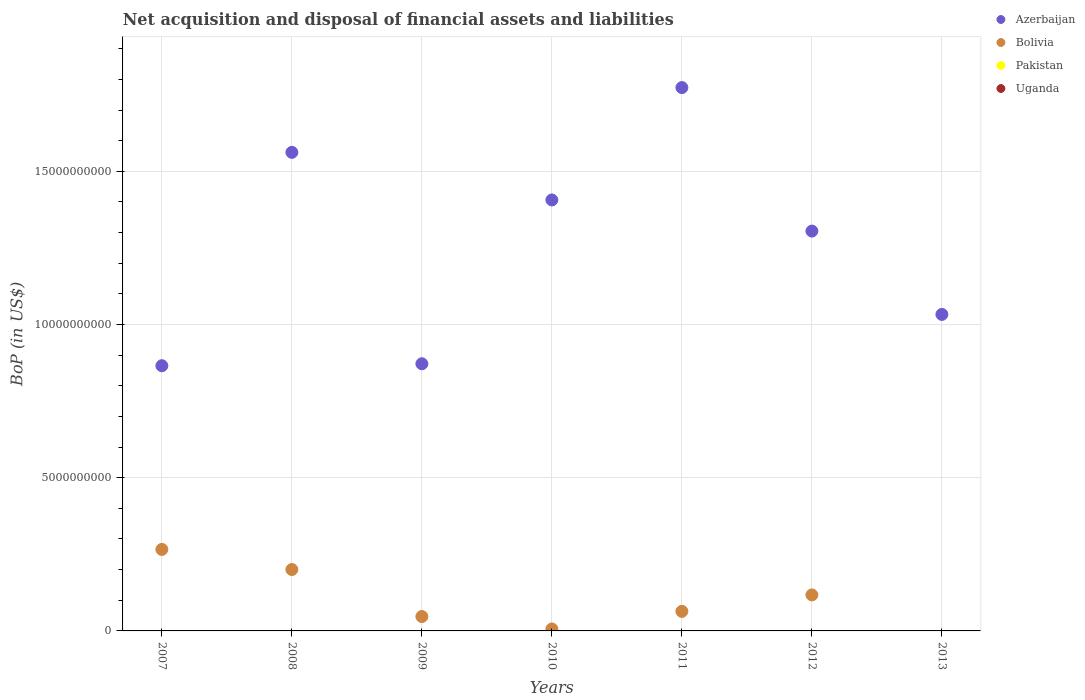How many different coloured dotlines are there?
Your response must be concise. 2. Is the number of dotlines equal to the number of legend labels?
Your answer should be very brief. No. Across all years, what is the maximum Balance of Payments in Bolivia?
Make the answer very short. 2.66e+09. Across all years, what is the minimum Balance of Payments in Azerbaijan?
Your answer should be very brief. 8.66e+09. What is the total Balance of Payments in Azerbaijan in the graph?
Provide a short and direct response. 8.82e+1. What is the difference between the Balance of Payments in Azerbaijan in 2008 and that in 2013?
Keep it short and to the point. 5.29e+09. What is the difference between the Balance of Payments in Azerbaijan in 2010 and the Balance of Payments in Uganda in 2012?
Your answer should be very brief. 1.41e+1. In the year 2012, what is the difference between the Balance of Payments in Bolivia and Balance of Payments in Azerbaijan?
Offer a terse response. -1.19e+1. In how many years, is the Balance of Payments in Bolivia greater than 4000000000 US$?
Give a very brief answer. 0. What is the ratio of the Balance of Payments in Azerbaijan in 2009 to that in 2012?
Offer a terse response. 0.67. What is the difference between the highest and the second highest Balance of Payments in Azerbaijan?
Your answer should be compact. 2.11e+09. What is the difference between the highest and the lowest Balance of Payments in Bolivia?
Your response must be concise. 2.66e+09. Is it the case that in every year, the sum of the Balance of Payments in Azerbaijan and Balance of Payments in Bolivia  is greater than the Balance of Payments in Uganda?
Offer a terse response. Yes. Does the Balance of Payments in Uganda monotonically increase over the years?
Give a very brief answer. No. Is the Balance of Payments in Uganda strictly less than the Balance of Payments in Azerbaijan over the years?
Provide a short and direct response. Yes. What is the difference between two consecutive major ticks on the Y-axis?
Your response must be concise. 5.00e+09. Does the graph contain any zero values?
Provide a succinct answer. Yes. Does the graph contain grids?
Offer a terse response. Yes. How many legend labels are there?
Offer a terse response. 4. What is the title of the graph?
Provide a succinct answer. Net acquisition and disposal of financial assets and liabilities. Does "Trinidad and Tobago" appear as one of the legend labels in the graph?
Make the answer very short. No. What is the label or title of the X-axis?
Offer a terse response. Years. What is the label or title of the Y-axis?
Your response must be concise. BoP (in US$). What is the BoP (in US$) in Azerbaijan in 2007?
Offer a terse response. 8.66e+09. What is the BoP (in US$) of Bolivia in 2007?
Keep it short and to the point. 2.66e+09. What is the BoP (in US$) in Uganda in 2007?
Ensure brevity in your answer.  0. What is the BoP (in US$) in Azerbaijan in 2008?
Provide a short and direct response. 1.56e+1. What is the BoP (in US$) in Bolivia in 2008?
Ensure brevity in your answer.  2.00e+09. What is the BoP (in US$) in Uganda in 2008?
Provide a short and direct response. 0. What is the BoP (in US$) of Azerbaijan in 2009?
Give a very brief answer. 8.72e+09. What is the BoP (in US$) of Bolivia in 2009?
Offer a terse response. 4.71e+08. What is the BoP (in US$) in Pakistan in 2009?
Give a very brief answer. 0. What is the BoP (in US$) of Azerbaijan in 2010?
Give a very brief answer. 1.41e+1. What is the BoP (in US$) of Bolivia in 2010?
Offer a terse response. 6.43e+07. What is the BoP (in US$) of Uganda in 2010?
Give a very brief answer. 0. What is the BoP (in US$) of Azerbaijan in 2011?
Make the answer very short. 1.77e+1. What is the BoP (in US$) in Bolivia in 2011?
Your answer should be very brief. 6.38e+08. What is the BoP (in US$) of Pakistan in 2011?
Provide a succinct answer. 0. What is the BoP (in US$) of Azerbaijan in 2012?
Provide a succinct answer. 1.30e+1. What is the BoP (in US$) of Bolivia in 2012?
Offer a very short reply. 1.18e+09. What is the BoP (in US$) in Pakistan in 2012?
Provide a succinct answer. 0. What is the BoP (in US$) in Uganda in 2012?
Your answer should be very brief. 0. What is the BoP (in US$) in Azerbaijan in 2013?
Ensure brevity in your answer.  1.03e+1. What is the BoP (in US$) of Bolivia in 2013?
Your answer should be compact. 0. Across all years, what is the maximum BoP (in US$) in Azerbaijan?
Ensure brevity in your answer.  1.77e+1. Across all years, what is the maximum BoP (in US$) in Bolivia?
Offer a terse response. 2.66e+09. Across all years, what is the minimum BoP (in US$) in Azerbaijan?
Make the answer very short. 8.66e+09. Across all years, what is the minimum BoP (in US$) of Bolivia?
Provide a short and direct response. 0. What is the total BoP (in US$) of Azerbaijan in the graph?
Your answer should be compact. 8.82e+1. What is the total BoP (in US$) in Bolivia in the graph?
Offer a terse response. 7.01e+09. What is the difference between the BoP (in US$) of Azerbaijan in 2007 and that in 2008?
Provide a succinct answer. -6.96e+09. What is the difference between the BoP (in US$) of Bolivia in 2007 and that in 2008?
Provide a short and direct response. 6.56e+08. What is the difference between the BoP (in US$) in Azerbaijan in 2007 and that in 2009?
Give a very brief answer. -6.39e+07. What is the difference between the BoP (in US$) in Bolivia in 2007 and that in 2009?
Offer a very short reply. 2.19e+09. What is the difference between the BoP (in US$) in Azerbaijan in 2007 and that in 2010?
Offer a very short reply. -5.41e+09. What is the difference between the BoP (in US$) in Bolivia in 2007 and that in 2010?
Give a very brief answer. 2.60e+09. What is the difference between the BoP (in US$) in Azerbaijan in 2007 and that in 2011?
Ensure brevity in your answer.  -9.08e+09. What is the difference between the BoP (in US$) of Bolivia in 2007 and that in 2011?
Your response must be concise. 2.02e+09. What is the difference between the BoP (in US$) of Azerbaijan in 2007 and that in 2012?
Offer a terse response. -4.39e+09. What is the difference between the BoP (in US$) in Bolivia in 2007 and that in 2012?
Provide a short and direct response. 1.48e+09. What is the difference between the BoP (in US$) of Azerbaijan in 2007 and that in 2013?
Make the answer very short. -1.67e+09. What is the difference between the BoP (in US$) in Azerbaijan in 2008 and that in 2009?
Your answer should be compact. 6.90e+09. What is the difference between the BoP (in US$) of Bolivia in 2008 and that in 2009?
Keep it short and to the point. 1.53e+09. What is the difference between the BoP (in US$) in Azerbaijan in 2008 and that in 2010?
Ensure brevity in your answer.  1.55e+09. What is the difference between the BoP (in US$) in Bolivia in 2008 and that in 2010?
Ensure brevity in your answer.  1.94e+09. What is the difference between the BoP (in US$) of Azerbaijan in 2008 and that in 2011?
Give a very brief answer. -2.11e+09. What is the difference between the BoP (in US$) in Bolivia in 2008 and that in 2011?
Provide a short and direct response. 1.37e+09. What is the difference between the BoP (in US$) of Azerbaijan in 2008 and that in 2012?
Provide a short and direct response. 2.57e+09. What is the difference between the BoP (in US$) of Bolivia in 2008 and that in 2012?
Make the answer very short. 8.28e+08. What is the difference between the BoP (in US$) in Azerbaijan in 2008 and that in 2013?
Keep it short and to the point. 5.29e+09. What is the difference between the BoP (in US$) in Azerbaijan in 2009 and that in 2010?
Your answer should be very brief. -5.35e+09. What is the difference between the BoP (in US$) in Bolivia in 2009 and that in 2010?
Make the answer very short. 4.06e+08. What is the difference between the BoP (in US$) in Azerbaijan in 2009 and that in 2011?
Your answer should be very brief. -9.01e+09. What is the difference between the BoP (in US$) in Bolivia in 2009 and that in 2011?
Offer a terse response. -1.67e+08. What is the difference between the BoP (in US$) in Azerbaijan in 2009 and that in 2012?
Give a very brief answer. -4.33e+09. What is the difference between the BoP (in US$) in Bolivia in 2009 and that in 2012?
Provide a succinct answer. -7.05e+08. What is the difference between the BoP (in US$) of Azerbaijan in 2009 and that in 2013?
Offer a terse response. -1.61e+09. What is the difference between the BoP (in US$) of Azerbaijan in 2010 and that in 2011?
Provide a succinct answer. -3.67e+09. What is the difference between the BoP (in US$) in Bolivia in 2010 and that in 2011?
Provide a succinct answer. -5.74e+08. What is the difference between the BoP (in US$) in Azerbaijan in 2010 and that in 2012?
Keep it short and to the point. 1.02e+09. What is the difference between the BoP (in US$) in Bolivia in 2010 and that in 2012?
Give a very brief answer. -1.11e+09. What is the difference between the BoP (in US$) in Azerbaijan in 2010 and that in 2013?
Give a very brief answer. 3.74e+09. What is the difference between the BoP (in US$) of Azerbaijan in 2011 and that in 2012?
Provide a succinct answer. 4.68e+09. What is the difference between the BoP (in US$) in Bolivia in 2011 and that in 2012?
Ensure brevity in your answer.  -5.38e+08. What is the difference between the BoP (in US$) in Azerbaijan in 2011 and that in 2013?
Provide a short and direct response. 7.40e+09. What is the difference between the BoP (in US$) in Azerbaijan in 2012 and that in 2013?
Give a very brief answer. 2.72e+09. What is the difference between the BoP (in US$) of Azerbaijan in 2007 and the BoP (in US$) of Bolivia in 2008?
Keep it short and to the point. 6.65e+09. What is the difference between the BoP (in US$) of Azerbaijan in 2007 and the BoP (in US$) of Bolivia in 2009?
Offer a very short reply. 8.18e+09. What is the difference between the BoP (in US$) of Azerbaijan in 2007 and the BoP (in US$) of Bolivia in 2010?
Offer a very short reply. 8.59e+09. What is the difference between the BoP (in US$) of Azerbaijan in 2007 and the BoP (in US$) of Bolivia in 2011?
Offer a terse response. 8.02e+09. What is the difference between the BoP (in US$) of Azerbaijan in 2007 and the BoP (in US$) of Bolivia in 2012?
Make the answer very short. 7.48e+09. What is the difference between the BoP (in US$) in Azerbaijan in 2008 and the BoP (in US$) in Bolivia in 2009?
Offer a terse response. 1.51e+1. What is the difference between the BoP (in US$) in Azerbaijan in 2008 and the BoP (in US$) in Bolivia in 2010?
Keep it short and to the point. 1.56e+1. What is the difference between the BoP (in US$) in Azerbaijan in 2008 and the BoP (in US$) in Bolivia in 2011?
Offer a terse response. 1.50e+1. What is the difference between the BoP (in US$) in Azerbaijan in 2008 and the BoP (in US$) in Bolivia in 2012?
Your answer should be very brief. 1.44e+1. What is the difference between the BoP (in US$) in Azerbaijan in 2009 and the BoP (in US$) in Bolivia in 2010?
Make the answer very short. 8.65e+09. What is the difference between the BoP (in US$) in Azerbaijan in 2009 and the BoP (in US$) in Bolivia in 2011?
Your answer should be very brief. 8.08e+09. What is the difference between the BoP (in US$) in Azerbaijan in 2009 and the BoP (in US$) in Bolivia in 2012?
Offer a very short reply. 7.54e+09. What is the difference between the BoP (in US$) in Azerbaijan in 2010 and the BoP (in US$) in Bolivia in 2011?
Offer a terse response. 1.34e+1. What is the difference between the BoP (in US$) in Azerbaijan in 2010 and the BoP (in US$) in Bolivia in 2012?
Make the answer very short. 1.29e+1. What is the difference between the BoP (in US$) of Azerbaijan in 2011 and the BoP (in US$) of Bolivia in 2012?
Provide a succinct answer. 1.66e+1. What is the average BoP (in US$) of Azerbaijan per year?
Make the answer very short. 1.26e+1. What is the average BoP (in US$) of Bolivia per year?
Give a very brief answer. 1.00e+09. What is the average BoP (in US$) in Pakistan per year?
Your answer should be compact. 0. What is the average BoP (in US$) of Uganda per year?
Provide a short and direct response. 0. In the year 2007, what is the difference between the BoP (in US$) of Azerbaijan and BoP (in US$) of Bolivia?
Provide a short and direct response. 6.00e+09. In the year 2008, what is the difference between the BoP (in US$) in Azerbaijan and BoP (in US$) in Bolivia?
Your answer should be very brief. 1.36e+1. In the year 2009, what is the difference between the BoP (in US$) in Azerbaijan and BoP (in US$) in Bolivia?
Keep it short and to the point. 8.25e+09. In the year 2010, what is the difference between the BoP (in US$) in Azerbaijan and BoP (in US$) in Bolivia?
Your answer should be compact. 1.40e+1. In the year 2011, what is the difference between the BoP (in US$) of Azerbaijan and BoP (in US$) of Bolivia?
Offer a terse response. 1.71e+1. In the year 2012, what is the difference between the BoP (in US$) of Azerbaijan and BoP (in US$) of Bolivia?
Make the answer very short. 1.19e+1. What is the ratio of the BoP (in US$) of Azerbaijan in 2007 to that in 2008?
Provide a succinct answer. 0.55. What is the ratio of the BoP (in US$) of Bolivia in 2007 to that in 2008?
Offer a terse response. 1.33. What is the ratio of the BoP (in US$) in Bolivia in 2007 to that in 2009?
Give a very brief answer. 5.65. What is the ratio of the BoP (in US$) of Azerbaijan in 2007 to that in 2010?
Your answer should be very brief. 0.62. What is the ratio of the BoP (in US$) of Bolivia in 2007 to that in 2010?
Make the answer very short. 41.38. What is the ratio of the BoP (in US$) of Azerbaijan in 2007 to that in 2011?
Your response must be concise. 0.49. What is the ratio of the BoP (in US$) of Bolivia in 2007 to that in 2011?
Your answer should be very brief. 4.17. What is the ratio of the BoP (in US$) of Azerbaijan in 2007 to that in 2012?
Provide a short and direct response. 0.66. What is the ratio of the BoP (in US$) in Bolivia in 2007 to that in 2012?
Provide a short and direct response. 2.26. What is the ratio of the BoP (in US$) in Azerbaijan in 2007 to that in 2013?
Keep it short and to the point. 0.84. What is the ratio of the BoP (in US$) of Azerbaijan in 2008 to that in 2009?
Ensure brevity in your answer.  1.79. What is the ratio of the BoP (in US$) of Bolivia in 2008 to that in 2009?
Provide a short and direct response. 4.26. What is the ratio of the BoP (in US$) in Azerbaijan in 2008 to that in 2010?
Provide a succinct answer. 1.11. What is the ratio of the BoP (in US$) in Bolivia in 2008 to that in 2010?
Provide a succinct answer. 31.17. What is the ratio of the BoP (in US$) of Azerbaijan in 2008 to that in 2011?
Offer a very short reply. 0.88. What is the ratio of the BoP (in US$) of Bolivia in 2008 to that in 2011?
Make the answer very short. 3.14. What is the ratio of the BoP (in US$) of Azerbaijan in 2008 to that in 2012?
Offer a very short reply. 1.2. What is the ratio of the BoP (in US$) of Bolivia in 2008 to that in 2012?
Provide a short and direct response. 1.7. What is the ratio of the BoP (in US$) in Azerbaijan in 2008 to that in 2013?
Your response must be concise. 1.51. What is the ratio of the BoP (in US$) in Azerbaijan in 2009 to that in 2010?
Your answer should be compact. 0.62. What is the ratio of the BoP (in US$) in Bolivia in 2009 to that in 2010?
Give a very brief answer. 7.32. What is the ratio of the BoP (in US$) of Azerbaijan in 2009 to that in 2011?
Your answer should be very brief. 0.49. What is the ratio of the BoP (in US$) of Bolivia in 2009 to that in 2011?
Offer a terse response. 0.74. What is the ratio of the BoP (in US$) in Azerbaijan in 2009 to that in 2012?
Provide a short and direct response. 0.67. What is the ratio of the BoP (in US$) in Bolivia in 2009 to that in 2012?
Offer a very short reply. 0.4. What is the ratio of the BoP (in US$) in Azerbaijan in 2009 to that in 2013?
Offer a very short reply. 0.84. What is the ratio of the BoP (in US$) of Azerbaijan in 2010 to that in 2011?
Your answer should be compact. 0.79. What is the ratio of the BoP (in US$) in Bolivia in 2010 to that in 2011?
Provide a succinct answer. 0.1. What is the ratio of the BoP (in US$) in Azerbaijan in 2010 to that in 2012?
Give a very brief answer. 1.08. What is the ratio of the BoP (in US$) of Bolivia in 2010 to that in 2012?
Provide a short and direct response. 0.05. What is the ratio of the BoP (in US$) in Azerbaijan in 2010 to that in 2013?
Your answer should be compact. 1.36. What is the ratio of the BoP (in US$) of Azerbaijan in 2011 to that in 2012?
Your response must be concise. 1.36. What is the ratio of the BoP (in US$) in Bolivia in 2011 to that in 2012?
Your answer should be very brief. 0.54. What is the ratio of the BoP (in US$) in Azerbaijan in 2011 to that in 2013?
Make the answer very short. 1.72. What is the ratio of the BoP (in US$) of Azerbaijan in 2012 to that in 2013?
Keep it short and to the point. 1.26. What is the difference between the highest and the second highest BoP (in US$) of Azerbaijan?
Your response must be concise. 2.11e+09. What is the difference between the highest and the second highest BoP (in US$) in Bolivia?
Keep it short and to the point. 6.56e+08. What is the difference between the highest and the lowest BoP (in US$) in Azerbaijan?
Provide a succinct answer. 9.08e+09. What is the difference between the highest and the lowest BoP (in US$) in Bolivia?
Your answer should be very brief. 2.66e+09. 